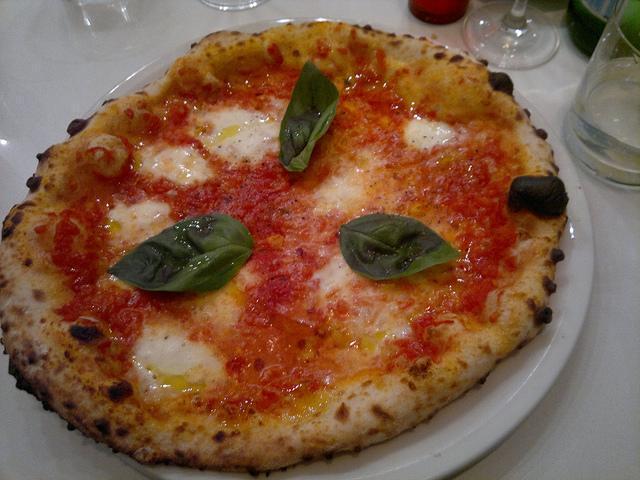How many pizzas are visible?
Give a very brief answer. 1. How many mice are in this scene?
Give a very brief answer. 0. 